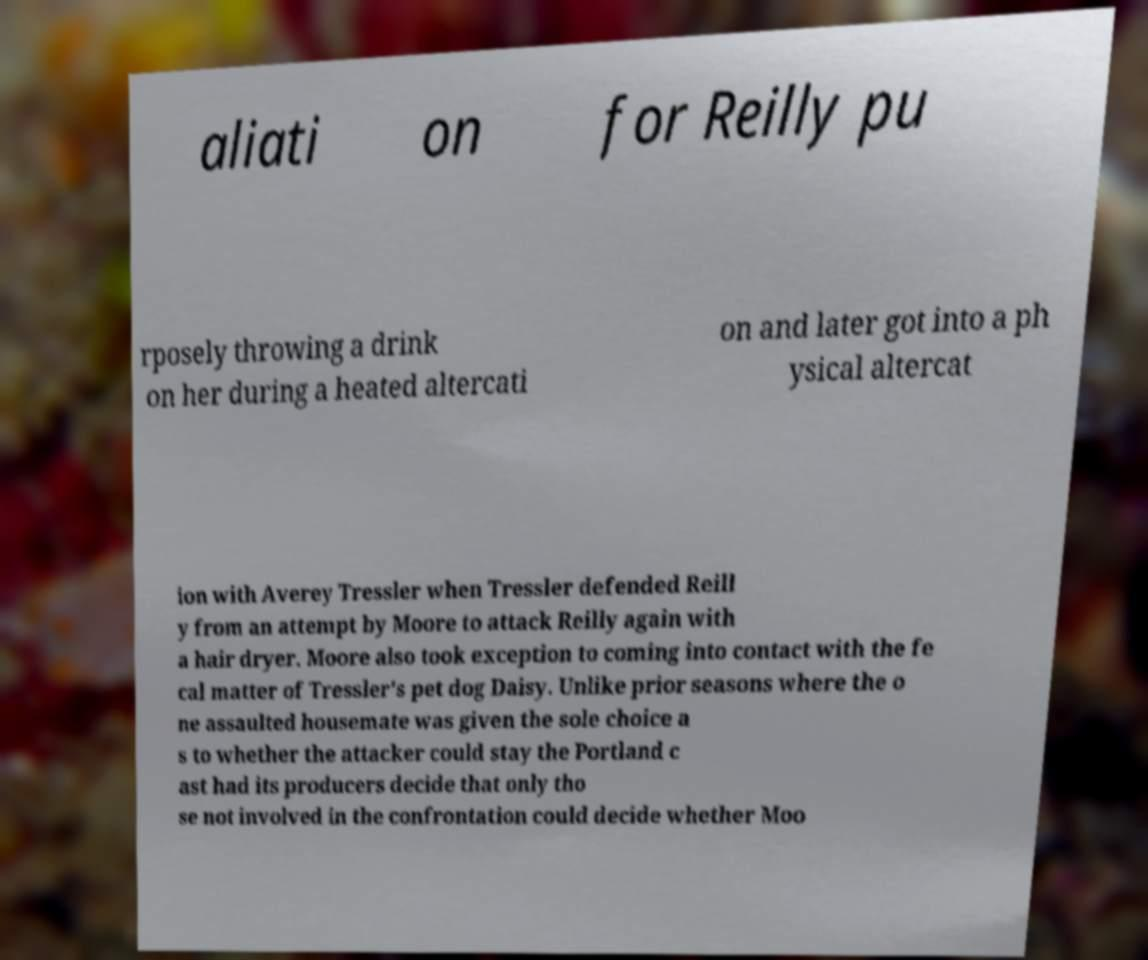Could you assist in decoding the text presented in this image and type it out clearly? aliati on for Reilly pu rposely throwing a drink on her during a heated altercati on and later got into a ph ysical altercat ion with Averey Tressler when Tressler defended Reill y from an attempt by Moore to attack Reilly again with a hair dryer. Moore also took exception to coming into contact with the fe cal matter of Tressler's pet dog Daisy. Unlike prior seasons where the o ne assaulted housemate was given the sole choice a s to whether the attacker could stay the Portland c ast had its producers decide that only tho se not involved in the confrontation could decide whether Moo 